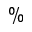Convert formula to latex. <formula><loc_0><loc_0><loc_500><loc_500>\%</formula> 